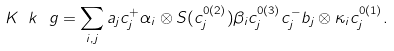Convert formula to latex. <formula><loc_0><loc_0><loc_500><loc_500>K _ { \ } k ^ { \ } g = \sum _ { i , j } a _ { j } c _ { j } ^ { + } \alpha _ { i } \otimes S ( c _ { j } ^ { 0 ( 2 ) } ) \beta _ { i } c _ { j } ^ { 0 ( 3 ) } c _ { j } ^ { - } b _ { j } \otimes \kappa _ { i } c _ { j } ^ { 0 ( 1 ) } .</formula> 